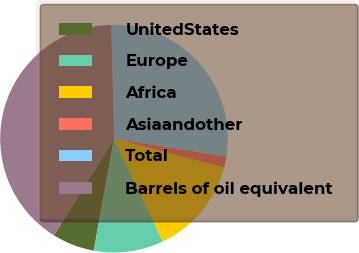Convert chart to OTSL. <chart><loc_0><loc_0><loc_500><loc_500><pie_chart><fcel>UnitedStates<fcel>Europe<fcel>Africa<fcel>Asiaandother<fcel>Total<fcel>Barrels of oil equivalent<nl><fcel>6.0%<fcel>9.91%<fcel>13.83%<fcel>1.6%<fcel>27.88%<fcel>40.78%<nl></chart> 